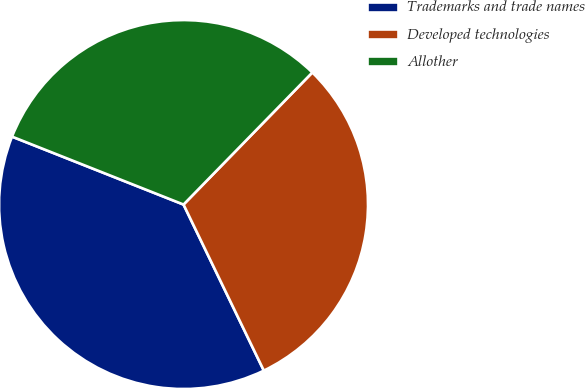Convert chart. <chart><loc_0><loc_0><loc_500><loc_500><pie_chart><fcel>Trademarks and trade names<fcel>Developed technologies<fcel>Allother<nl><fcel>38.17%<fcel>30.53%<fcel>31.3%<nl></chart> 